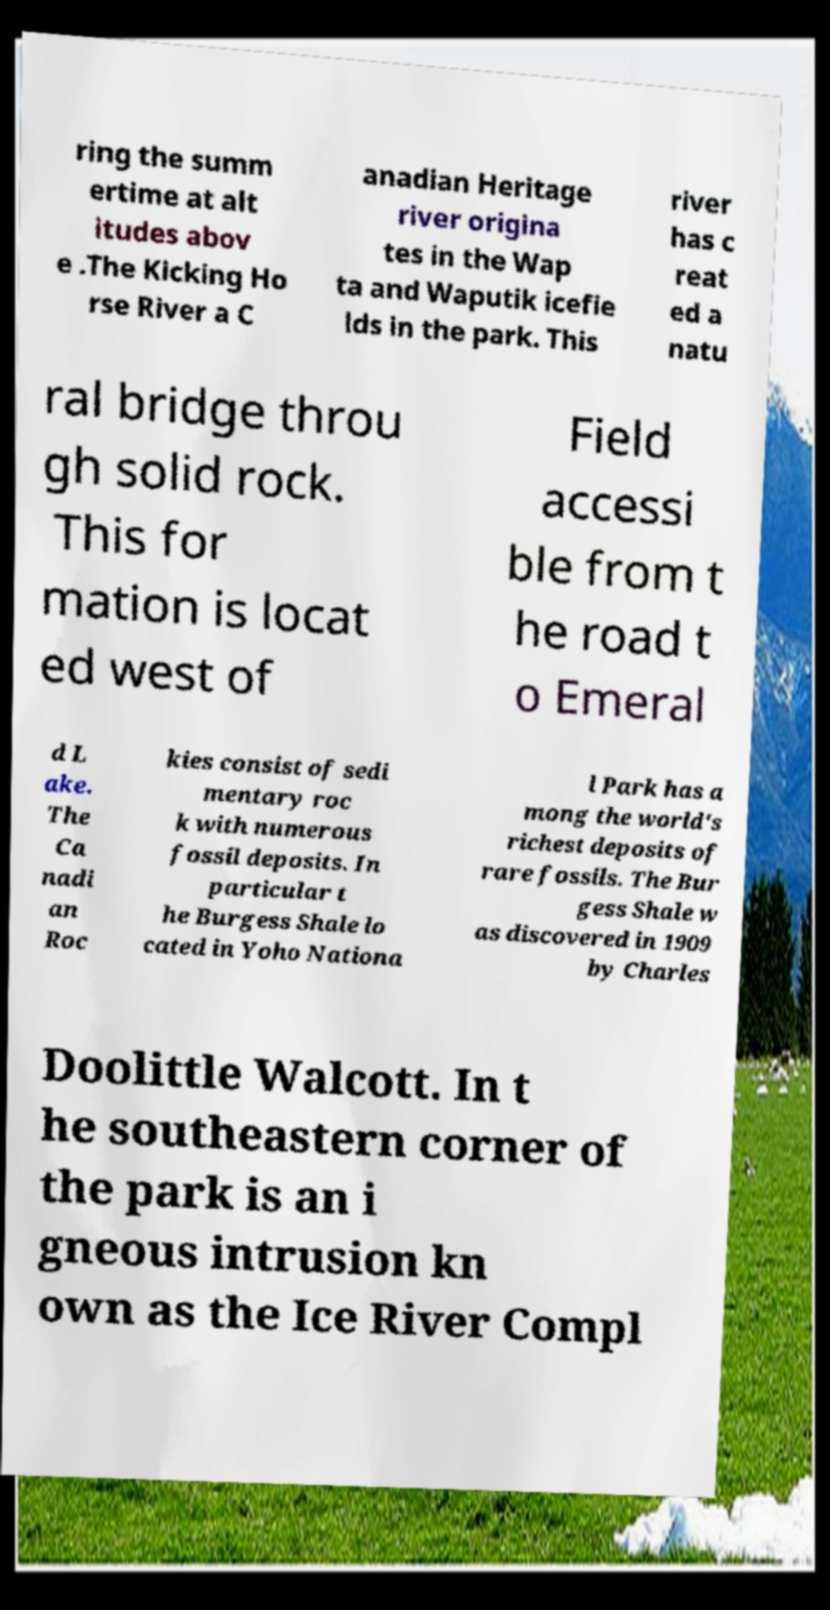Could you extract and type out the text from this image? ring the summ ertime at alt itudes abov e .The Kicking Ho rse River a C anadian Heritage river origina tes in the Wap ta and Waputik icefie lds in the park. This river has c reat ed a natu ral bridge throu gh solid rock. This for mation is locat ed west of Field accessi ble from t he road t o Emeral d L ake. The Ca nadi an Roc kies consist of sedi mentary roc k with numerous fossil deposits. In particular t he Burgess Shale lo cated in Yoho Nationa l Park has a mong the world's richest deposits of rare fossils. The Bur gess Shale w as discovered in 1909 by Charles Doolittle Walcott. In t he southeastern corner of the park is an i gneous intrusion kn own as the Ice River Compl 